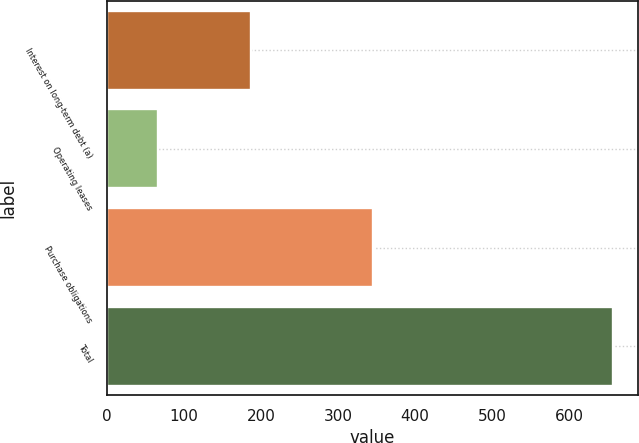<chart> <loc_0><loc_0><loc_500><loc_500><bar_chart><fcel>Interest on long-term debt (a)<fcel>Operating leases<fcel>Purchase obligations<fcel>Total<nl><fcel>187<fcel>66<fcel>345<fcel>656<nl></chart> 